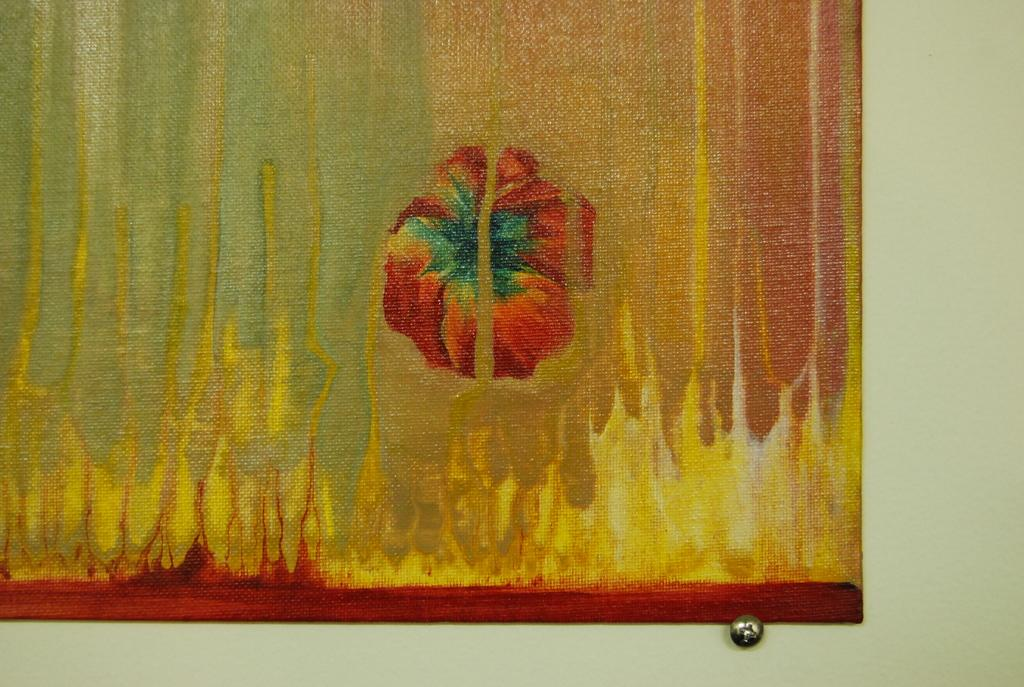What is on the wall in the image? There is a painting on the wall in the image. What type of rake is being used to attack the painting in the image? There is no rake or attack present in the image; it only features a painting on the wall. 